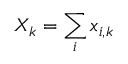Convert formula to latex. <formula><loc_0><loc_0><loc_500><loc_500>X _ { k } = \sum _ { i } x _ { i , k }</formula> 